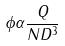<formula> <loc_0><loc_0><loc_500><loc_500>\phi \alpha \frac { Q } { N D ^ { 3 } }</formula> 